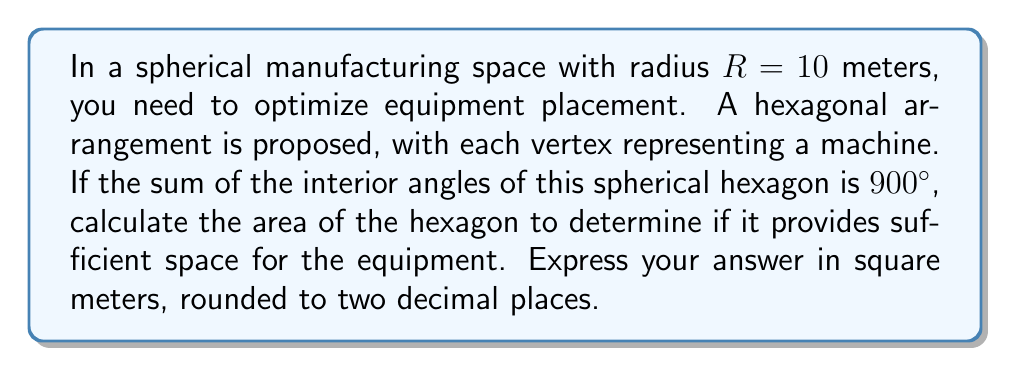Help me with this question. To solve this problem, we'll follow these steps:

1) In spherical geometry, the sum of the interior angles of a polygon with $n$ sides is given by the formula:

   $$S = (n-2)\pi + A\frac{n}{R^2}$$

   Where $S$ is the angle sum in radians, $A$ is the area of the polygon, and $R$ is the radius of the sphere.

2) We're given that the sum of the angles is 900°. Let's convert this to radians:

   $$900° = 900 \cdot \frac{\pi}{180} = 5\pi \text{ radians}$$

3) We know $n=6$ (hexagon), $R=10$, and $S=5\pi$. Let's substitute these into our formula:

   $$5\pi = (6-2)\pi + A\frac{6}{10^2}$$

4) Simplify:

   $$5\pi = 4\pi + \frac{6A}{100}$$

5) Subtract $4\pi$ from both sides:

   $$\pi = \frac{6A}{100}$$

6) Multiply both sides by 100/6:

   $$\frac{100\pi}{6} = A$$

7) Calculate the value:

   $$A = \frac{100\pi}{6} \approx 52.36 \text{ m}^2$$

8) Round to two decimal places:

   $$A \approx 52.36 \text{ m}^2$$
Answer: $52.36 \text{ m}^2$ 